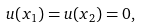<formula> <loc_0><loc_0><loc_500><loc_500>u ( x _ { 1 } ) = u ( x _ { 2 } ) = 0 ,</formula> 